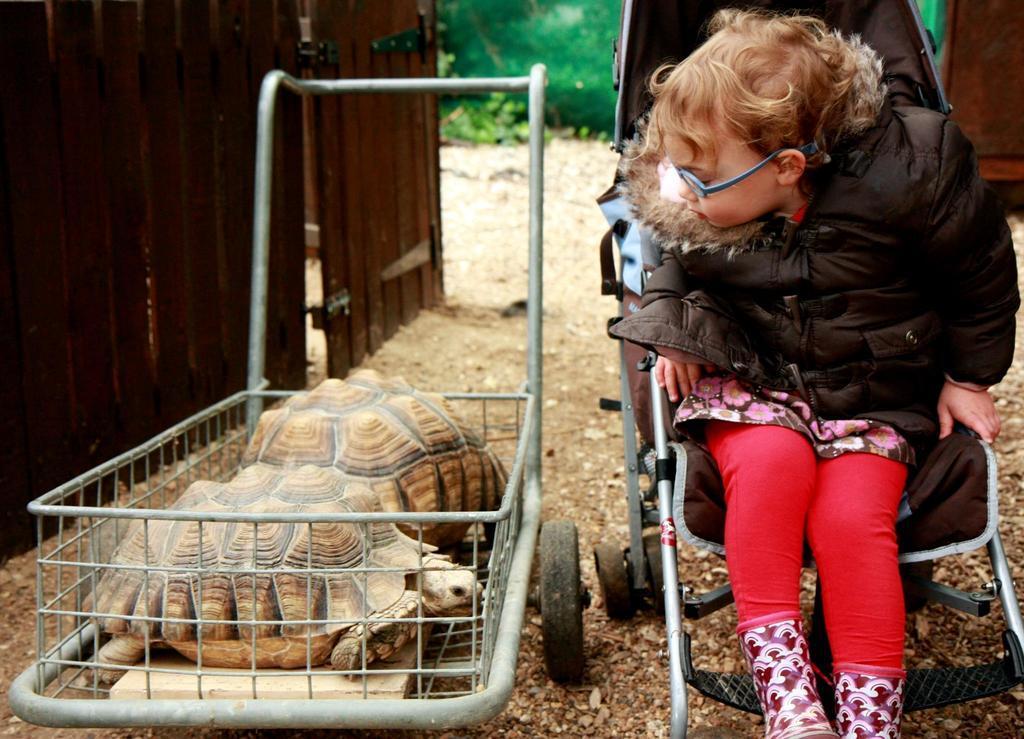Describe this image in one or two sentences. In this image there is a child sitting in the baby walker, beside her there is a trolley in which there are two tortoises. There is a wooden fence and in the background there is grass. 